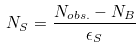<formula> <loc_0><loc_0><loc_500><loc_500>N _ { S } = \frac { N _ { o b s . } - N _ { B } } { \epsilon _ { S } }</formula> 